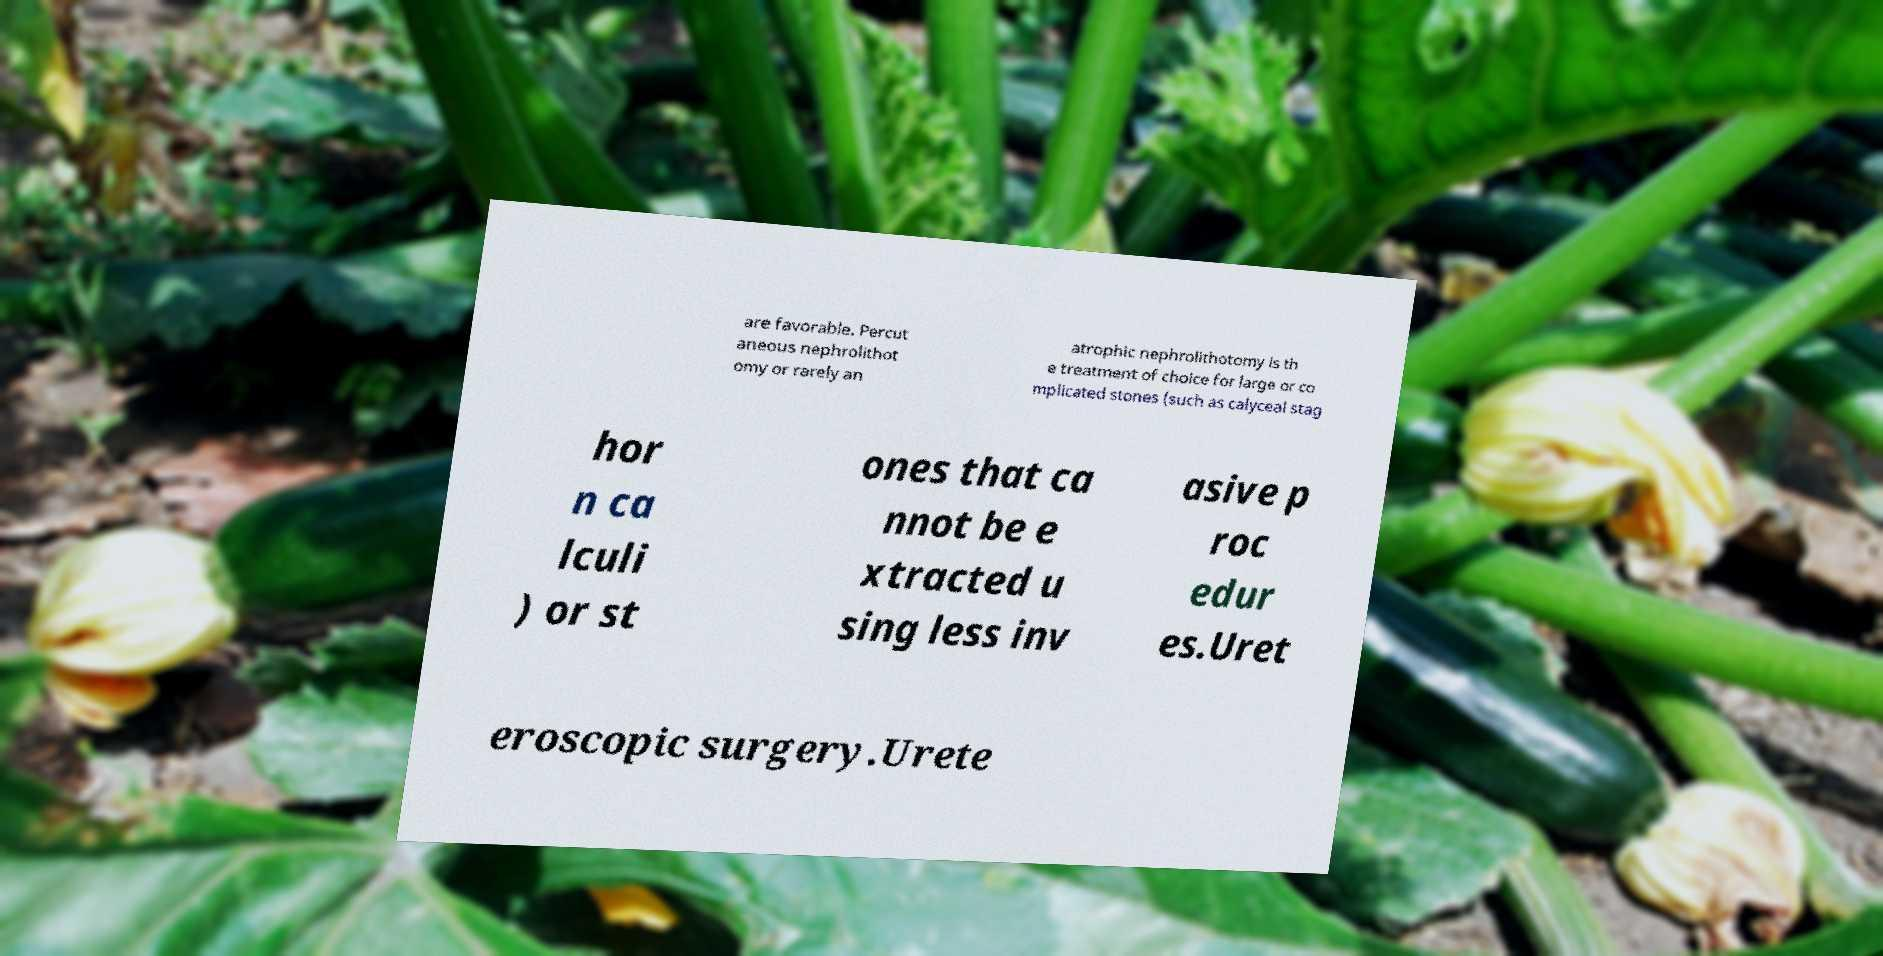There's text embedded in this image that I need extracted. Can you transcribe it verbatim? are favorable. Percut aneous nephrolithot omy or rarely an atrophic nephrolithotomy is th e treatment of choice for large or co mplicated stones (such as calyceal stag hor n ca lculi ) or st ones that ca nnot be e xtracted u sing less inv asive p roc edur es.Uret eroscopic surgery.Urete 